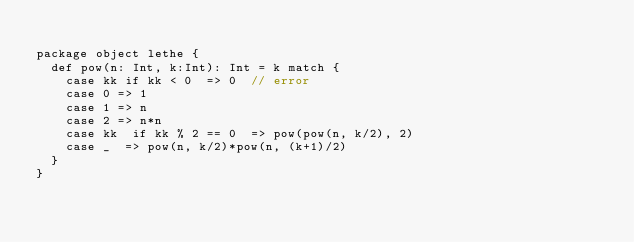Convert code to text. <code><loc_0><loc_0><loc_500><loc_500><_Scala_>
package object lethe {
  def pow(n: Int, k:Int): Int = k match {
    case kk if kk < 0  => 0  // error
    case 0 => 1
    case 1 => n
    case 2 => n*n
    case kk  if kk % 2 == 0  => pow(pow(n, k/2), 2)
    case _  => pow(n, k/2)*pow(n, (k+1)/2)
  }
}</code> 